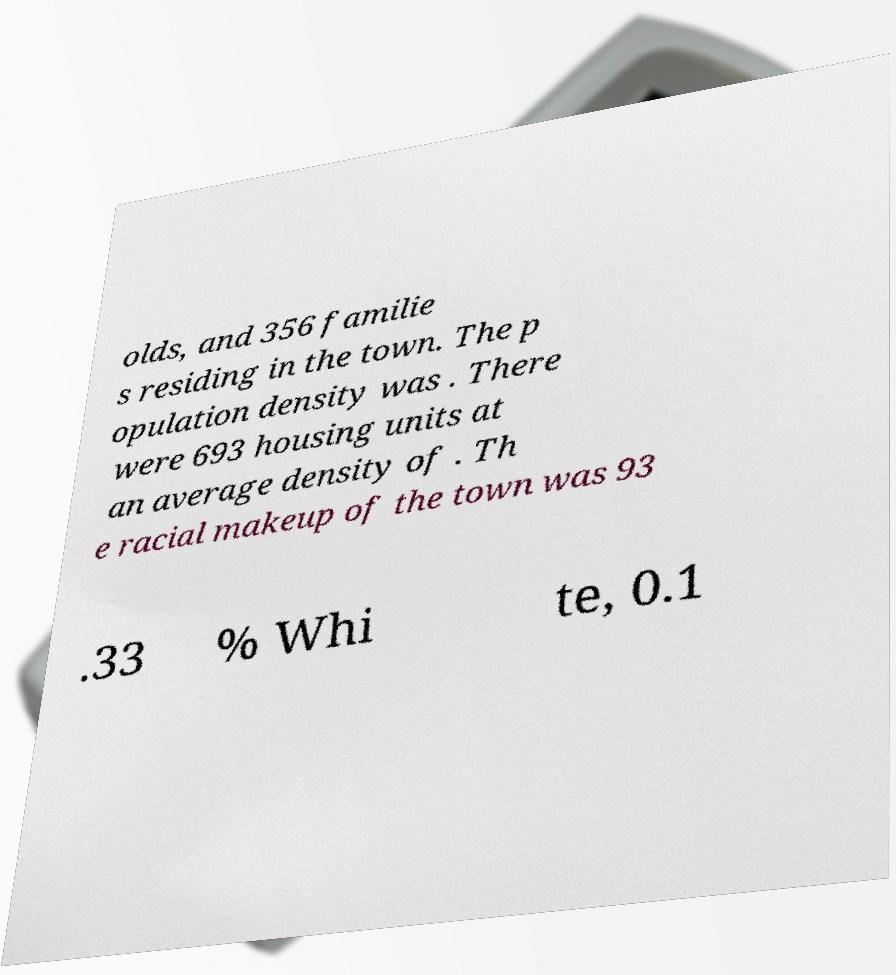Can you accurately transcribe the text from the provided image for me? olds, and 356 familie s residing in the town. The p opulation density was . There were 693 housing units at an average density of . Th e racial makeup of the town was 93 .33 % Whi te, 0.1 